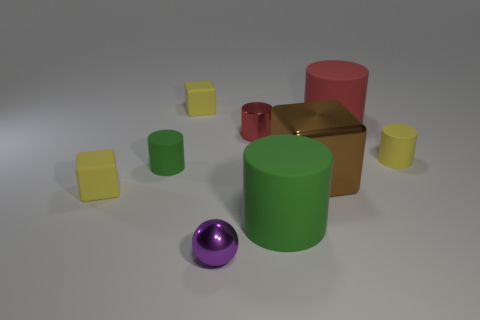Subtract all shiny cylinders. How many cylinders are left? 4 Subtract all yellow cylinders. How many cylinders are left? 4 Subtract all purple cylinders. Subtract all gray spheres. How many cylinders are left? 5 Subtract all blocks. How many objects are left? 6 Add 1 tiny metallic cylinders. How many tiny metallic cylinders exist? 2 Subtract 0 cyan blocks. How many objects are left? 9 Subtract all red shiny objects. Subtract all red things. How many objects are left? 6 Add 2 small purple metallic balls. How many small purple metallic balls are left? 3 